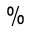<formula> <loc_0><loc_0><loc_500><loc_500>\%</formula> 